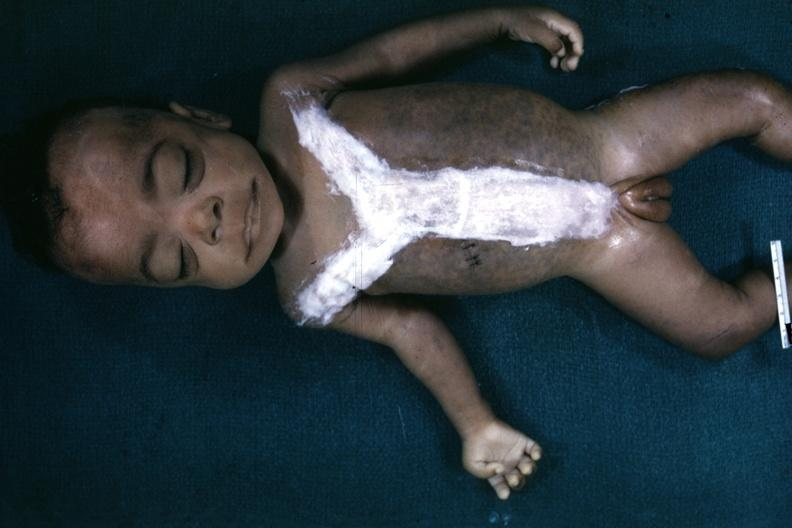what is opened to show simian crease quite good example?
Answer the question using a single word or phrase. Very representation of mongoloid facies and one hand 